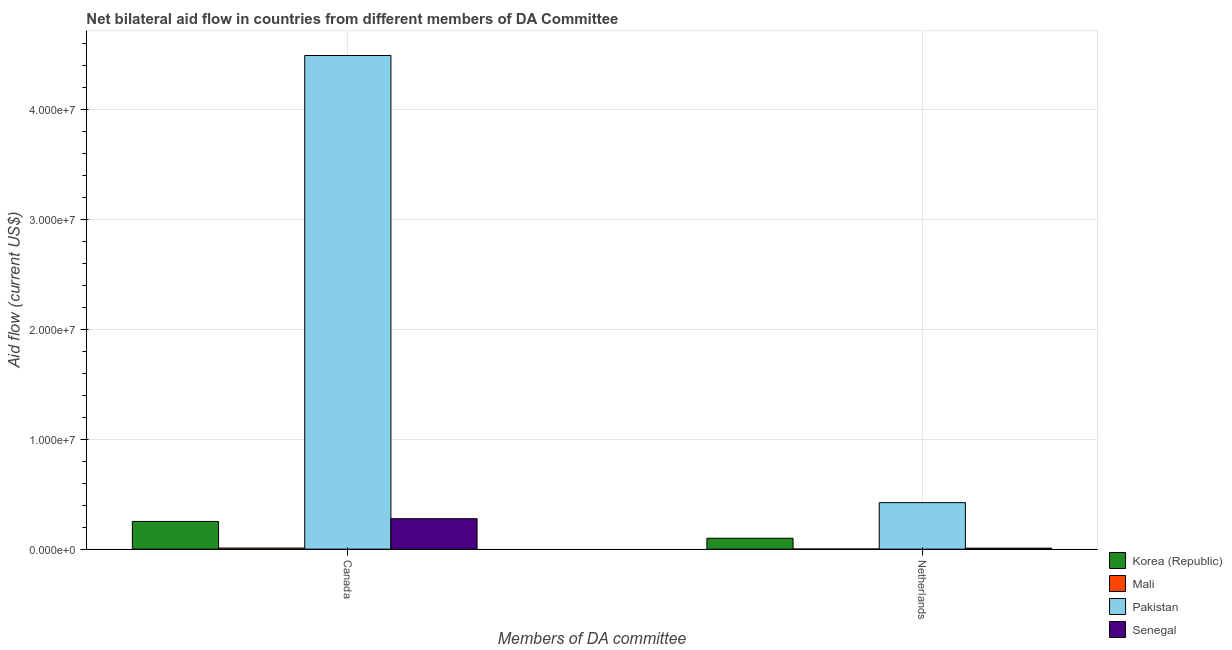Are the number of bars per tick equal to the number of legend labels?
Provide a short and direct response. Yes. How many bars are there on the 2nd tick from the right?
Keep it short and to the point. 4. What is the amount of aid given by netherlands in Mali?
Make the answer very short. 10000. Across all countries, what is the maximum amount of aid given by netherlands?
Your answer should be very brief. 4.23e+06. Across all countries, what is the minimum amount of aid given by canada?
Make the answer very short. 1.00e+05. In which country was the amount of aid given by canada minimum?
Your answer should be compact. Mali. What is the total amount of aid given by netherlands in the graph?
Give a very brief answer. 5.32e+06. What is the difference between the amount of aid given by canada in Korea (Republic) and that in Senegal?
Make the answer very short. -2.50e+05. What is the difference between the amount of aid given by netherlands in Mali and the amount of aid given by canada in Senegal?
Provide a short and direct response. -2.76e+06. What is the average amount of aid given by canada per country?
Offer a very short reply. 1.26e+07. What is the difference between the amount of aid given by netherlands and amount of aid given by canada in Mali?
Provide a succinct answer. -9.00e+04. In how many countries, is the amount of aid given by canada greater than 38000000 US$?
Your answer should be compact. 1. Is the amount of aid given by canada in Mali less than that in Pakistan?
Provide a succinct answer. Yes. What does the 1st bar from the right in Netherlands represents?
Provide a short and direct response. Senegal. Are all the bars in the graph horizontal?
Give a very brief answer. No. Are the values on the major ticks of Y-axis written in scientific E-notation?
Your answer should be very brief. Yes. Does the graph contain any zero values?
Your answer should be very brief. No. What is the title of the graph?
Offer a terse response. Net bilateral aid flow in countries from different members of DA Committee. Does "Comoros" appear as one of the legend labels in the graph?
Your answer should be compact. No. What is the label or title of the X-axis?
Ensure brevity in your answer.  Members of DA committee. What is the Aid flow (current US$) of Korea (Republic) in Canada?
Your answer should be very brief. 2.52e+06. What is the Aid flow (current US$) in Pakistan in Canada?
Your response must be concise. 4.49e+07. What is the Aid flow (current US$) of Senegal in Canada?
Ensure brevity in your answer.  2.77e+06. What is the Aid flow (current US$) in Korea (Republic) in Netherlands?
Ensure brevity in your answer.  9.90e+05. What is the Aid flow (current US$) of Mali in Netherlands?
Your answer should be compact. 10000. What is the Aid flow (current US$) in Pakistan in Netherlands?
Your response must be concise. 4.23e+06. What is the Aid flow (current US$) in Senegal in Netherlands?
Your answer should be very brief. 9.00e+04. Across all Members of DA committee, what is the maximum Aid flow (current US$) of Korea (Republic)?
Make the answer very short. 2.52e+06. Across all Members of DA committee, what is the maximum Aid flow (current US$) of Mali?
Your response must be concise. 1.00e+05. Across all Members of DA committee, what is the maximum Aid flow (current US$) of Pakistan?
Give a very brief answer. 4.49e+07. Across all Members of DA committee, what is the maximum Aid flow (current US$) of Senegal?
Keep it short and to the point. 2.77e+06. Across all Members of DA committee, what is the minimum Aid flow (current US$) in Korea (Republic)?
Your answer should be compact. 9.90e+05. Across all Members of DA committee, what is the minimum Aid flow (current US$) of Pakistan?
Your answer should be very brief. 4.23e+06. Across all Members of DA committee, what is the minimum Aid flow (current US$) in Senegal?
Provide a short and direct response. 9.00e+04. What is the total Aid flow (current US$) of Korea (Republic) in the graph?
Offer a terse response. 3.51e+06. What is the total Aid flow (current US$) in Pakistan in the graph?
Keep it short and to the point. 4.91e+07. What is the total Aid flow (current US$) of Senegal in the graph?
Provide a short and direct response. 2.86e+06. What is the difference between the Aid flow (current US$) in Korea (Republic) in Canada and that in Netherlands?
Offer a terse response. 1.53e+06. What is the difference between the Aid flow (current US$) in Pakistan in Canada and that in Netherlands?
Ensure brevity in your answer.  4.07e+07. What is the difference between the Aid flow (current US$) in Senegal in Canada and that in Netherlands?
Make the answer very short. 2.68e+06. What is the difference between the Aid flow (current US$) of Korea (Republic) in Canada and the Aid flow (current US$) of Mali in Netherlands?
Ensure brevity in your answer.  2.51e+06. What is the difference between the Aid flow (current US$) in Korea (Republic) in Canada and the Aid flow (current US$) in Pakistan in Netherlands?
Offer a terse response. -1.71e+06. What is the difference between the Aid flow (current US$) in Korea (Republic) in Canada and the Aid flow (current US$) in Senegal in Netherlands?
Provide a short and direct response. 2.43e+06. What is the difference between the Aid flow (current US$) of Mali in Canada and the Aid flow (current US$) of Pakistan in Netherlands?
Your response must be concise. -4.13e+06. What is the difference between the Aid flow (current US$) in Mali in Canada and the Aid flow (current US$) in Senegal in Netherlands?
Provide a short and direct response. 10000. What is the difference between the Aid flow (current US$) in Pakistan in Canada and the Aid flow (current US$) in Senegal in Netherlands?
Your answer should be compact. 4.48e+07. What is the average Aid flow (current US$) of Korea (Republic) per Members of DA committee?
Ensure brevity in your answer.  1.76e+06. What is the average Aid flow (current US$) of Mali per Members of DA committee?
Give a very brief answer. 5.50e+04. What is the average Aid flow (current US$) in Pakistan per Members of DA committee?
Offer a very short reply. 2.46e+07. What is the average Aid flow (current US$) of Senegal per Members of DA committee?
Offer a terse response. 1.43e+06. What is the difference between the Aid flow (current US$) of Korea (Republic) and Aid flow (current US$) of Mali in Canada?
Ensure brevity in your answer.  2.42e+06. What is the difference between the Aid flow (current US$) of Korea (Republic) and Aid flow (current US$) of Pakistan in Canada?
Keep it short and to the point. -4.24e+07. What is the difference between the Aid flow (current US$) in Mali and Aid flow (current US$) in Pakistan in Canada?
Provide a succinct answer. -4.48e+07. What is the difference between the Aid flow (current US$) in Mali and Aid flow (current US$) in Senegal in Canada?
Your response must be concise. -2.67e+06. What is the difference between the Aid flow (current US$) of Pakistan and Aid flow (current US$) of Senegal in Canada?
Your response must be concise. 4.21e+07. What is the difference between the Aid flow (current US$) of Korea (Republic) and Aid flow (current US$) of Mali in Netherlands?
Provide a short and direct response. 9.80e+05. What is the difference between the Aid flow (current US$) of Korea (Republic) and Aid flow (current US$) of Pakistan in Netherlands?
Provide a succinct answer. -3.24e+06. What is the difference between the Aid flow (current US$) of Korea (Republic) and Aid flow (current US$) of Senegal in Netherlands?
Ensure brevity in your answer.  9.00e+05. What is the difference between the Aid flow (current US$) in Mali and Aid flow (current US$) in Pakistan in Netherlands?
Keep it short and to the point. -4.22e+06. What is the difference between the Aid flow (current US$) in Pakistan and Aid flow (current US$) in Senegal in Netherlands?
Provide a short and direct response. 4.14e+06. What is the ratio of the Aid flow (current US$) in Korea (Republic) in Canada to that in Netherlands?
Offer a very short reply. 2.55. What is the ratio of the Aid flow (current US$) of Pakistan in Canada to that in Netherlands?
Provide a short and direct response. 10.61. What is the ratio of the Aid flow (current US$) in Senegal in Canada to that in Netherlands?
Offer a terse response. 30.78. What is the difference between the highest and the second highest Aid flow (current US$) of Korea (Republic)?
Your answer should be compact. 1.53e+06. What is the difference between the highest and the second highest Aid flow (current US$) in Pakistan?
Provide a short and direct response. 4.07e+07. What is the difference between the highest and the second highest Aid flow (current US$) in Senegal?
Offer a very short reply. 2.68e+06. What is the difference between the highest and the lowest Aid flow (current US$) of Korea (Republic)?
Your answer should be compact. 1.53e+06. What is the difference between the highest and the lowest Aid flow (current US$) in Pakistan?
Offer a terse response. 4.07e+07. What is the difference between the highest and the lowest Aid flow (current US$) of Senegal?
Offer a very short reply. 2.68e+06. 